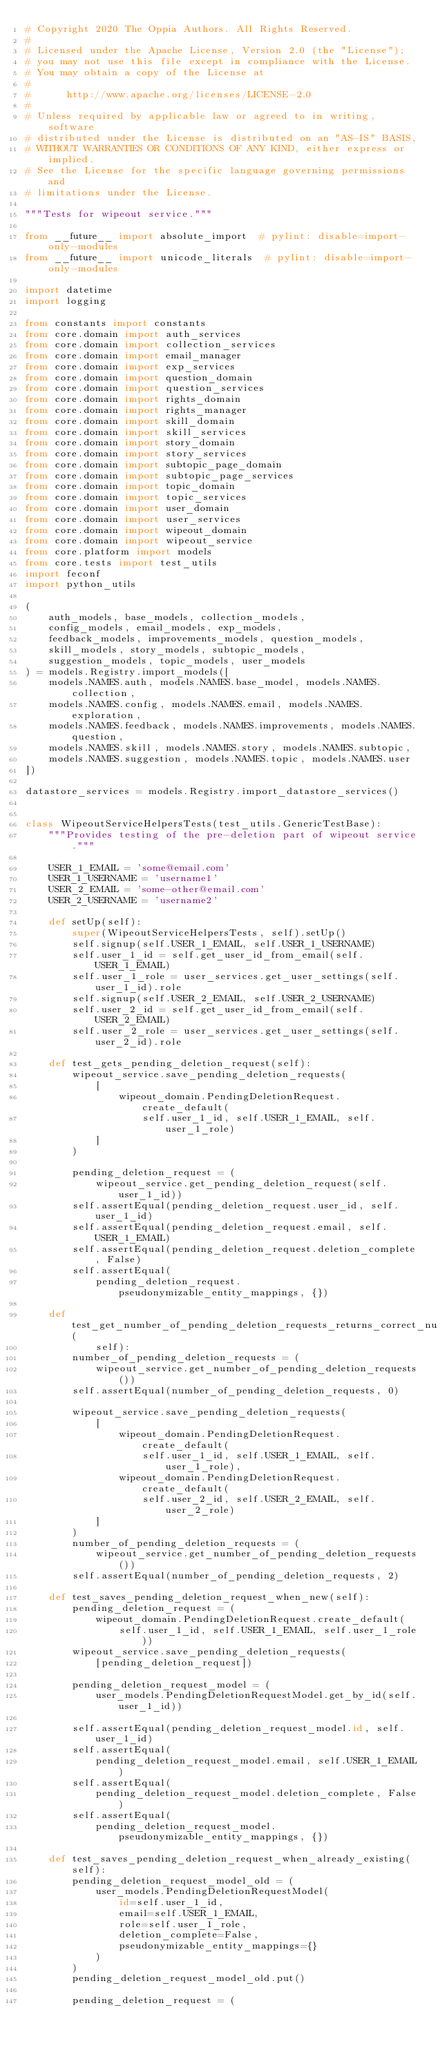<code> <loc_0><loc_0><loc_500><loc_500><_Python_># Copyright 2020 The Oppia Authors. All Rights Reserved.
#
# Licensed under the Apache License, Version 2.0 (the "License");
# you may not use this file except in compliance with the License.
# You may obtain a copy of the License at
#
#      http://www.apache.org/licenses/LICENSE-2.0
#
# Unless required by applicable law or agreed to in writing, software
# distributed under the License is distributed on an "AS-IS" BASIS,
# WITHOUT WARRANTIES OR CONDITIONS OF ANY KIND, either express or implied.
# See the License for the specific language governing permissions and
# limitations under the License.

"""Tests for wipeout service."""

from __future__ import absolute_import  # pylint: disable=import-only-modules
from __future__ import unicode_literals  # pylint: disable=import-only-modules

import datetime
import logging

from constants import constants
from core.domain import auth_services
from core.domain import collection_services
from core.domain import email_manager
from core.domain import exp_services
from core.domain import question_domain
from core.domain import question_services
from core.domain import rights_domain
from core.domain import rights_manager
from core.domain import skill_domain
from core.domain import skill_services
from core.domain import story_domain
from core.domain import story_services
from core.domain import subtopic_page_domain
from core.domain import subtopic_page_services
from core.domain import topic_domain
from core.domain import topic_services
from core.domain import user_domain
from core.domain import user_services
from core.domain import wipeout_domain
from core.domain import wipeout_service
from core.platform import models
from core.tests import test_utils
import feconf
import python_utils

(
    auth_models, base_models, collection_models,
    config_models, email_models, exp_models,
    feedback_models, improvements_models, question_models,
    skill_models, story_models, subtopic_models,
    suggestion_models, topic_models, user_models
) = models.Registry.import_models([
    models.NAMES.auth, models.NAMES.base_model, models.NAMES.collection,
    models.NAMES.config, models.NAMES.email, models.NAMES.exploration,
    models.NAMES.feedback, models.NAMES.improvements, models.NAMES.question,
    models.NAMES.skill, models.NAMES.story, models.NAMES.subtopic,
    models.NAMES.suggestion, models.NAMES.topic, models.NAMES.user
])

datastore_services = models.Registry.import_datastore_services()


class WipeoutServiceHelpersTests(test_utils.GenericTestBase):
    """Provides testing of the pre-deletion part of wipeout service."""

    USER_1_EMAIL = 'some@email.com'
    USER_1_USERNAME = 'username1'
    USER_2_EMAIL = 'some-other@email.com'
    USER_2_USERNAME = 'username2'

    def setUp(self):
        super(WipeoutServiceHelpersTests, self).setUp()
        self.signup(self.USER_1_EMAIL, self.USER_1_USERNAME)
        self.user_1_id = self.get_user_id_from_email(self.USER_1_EMAIL)
        self.user_1_role = user_services.get_user_settings(self.user_1_id).role
        self.signup(self.USER_2_EMAIL, self.USER_2_USERNAME)
        self.user_2_id = self.get_user_id_from_email(self.USER_2_EMAIL)
        self.user_2_role = user_services.get_user_settings(self.user_2_id).role

    def test_gets_pending_deletion_request(self):
        wipeout_service.save_pending_deletion_requests(
            [
                wipeout_domain.PendingDeletionRequest.create_default(
                    self.user_1_id, self.USER_1_EMAIL, self.user_1_role)
            ]
        )

        pending_deletion_request = (
            wipeout_service.get_pending_deletion_request(self.user_1_id))
        self.assertEqual(pending_deletion_request.user_id, self.user_1_id)
        self.assertEqual(pending_deletion_request.email, self.USER_1_EMAIL)
        self.assertEqual(pending_deletion_request.deletion_complete, False)
        self.assertEqual(
            pending_deletion_request.pseudonymizable_entity_mappings, {})

    def test_get_number_of_pending_deletion_requests_returns_correct_number(
            self):
        number_of_pending_deletion_requests = (
            wipeout_service.get_number_of_pending_deletion_requests())
        self.assertEqual(number_of_pending_deletion_requests, 0)

        wipeout_service.save_pending_deletion_requests(
            [
                wipeout_domain.PendingDeletionRequest.create_default(
                    self.user_1_id, self.USER_1_EMAIL, self.user_1_role),
                wipeout_domain.PendingDeletionRequest.create_default(
                    self.user_2_id, self.USER_2_EMAIL, self.user_2_role)
            ]
        )
        number_of_pending_deletion_requests = (
            wipeout_service.get_number_of_pending_deletion_requests())
        self.assertEqual(number_of_pending_deletion_requests, 2)

    def test_saves_pending_deletion_request_when_new(self):
        pending_deletion_request = (
            wipeout_domain.PendingDeletionRequest.create_default(
                self.user_1_id, self.USER_1_EMAIL, self.user_1_role))
        wipeout_service.save_pending_deletion_requests(
            [pending_deletion_request])

        pending_deletion_request_model = (
            user_models.PendingDeletionRequestModel.get_by_id(self.user_1_id))

        self.assertEqual(pending_deletion_request_model.id, self.user_1_id)
        self.assertEqual(
            pending_deletion_request_model.email, self.USER_1_EMAIL)
        self.assertEqual(
            pending_deletion_request_model.deletion_complete, False)
        self.assertEqual(
            pending_deletion_request_model.pseudonymizable_entity_mappings, {})

    def test_saves_pending_deletion_request_when_already_existing(self):
        pending_deletion_request_model_old = (
            user_models.PendingDeletionRequestModel(
                id=self.user_1_id,
                email=self.USER_1_EMAIL,
                role=self.user_1_role,
                deletion_complete=False,
                pseudonymizable_entity_mappings={}
            )
        )
        pending_deletion_request_model_old.put()

        pending_deletion_request = (</code> 